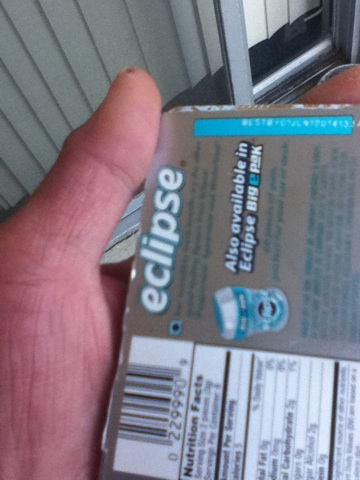Is this gum sugar-free? Eclipse gum typically offers sugar-free options, which can be identified by the 'sugar-free' label on the packaging. However, due to the blur, it is not possible to confirm from this image if this particular product is sugar-free. 